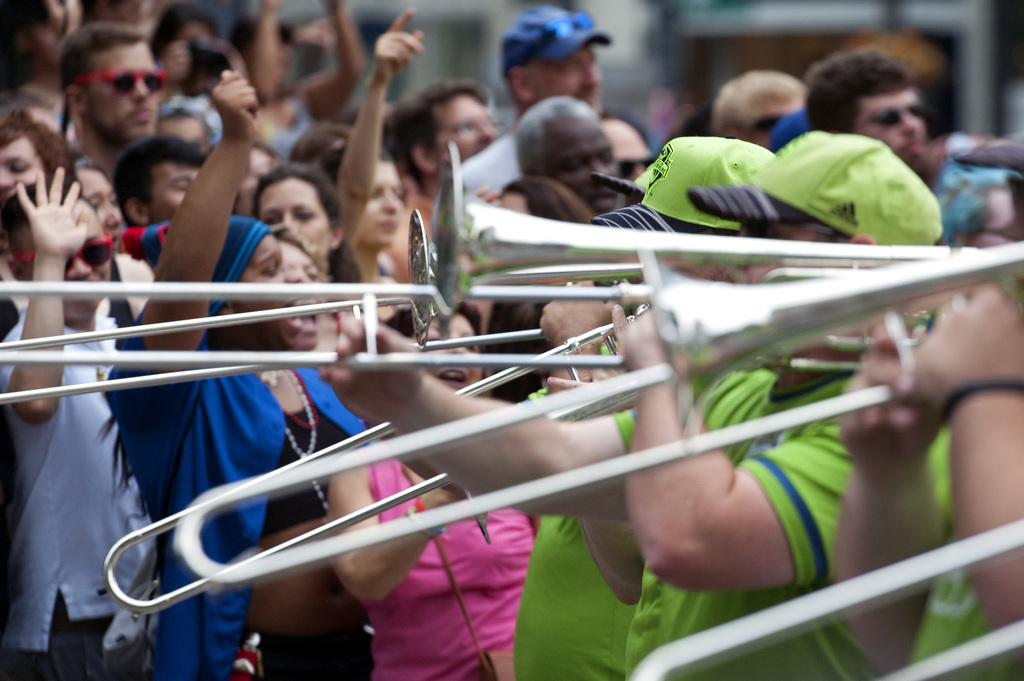How many men are present on the right side of the image? There are three men on the right side of the image. What are the men doing in the image? The men are standing and playing trumpets. Can you describe the background of the image? There is a crowd in the background of the image. What type of stocking is the grandfather wearing in the image? There is no grandfather or stocking present in the image. How many passengers are visible in the image? There is no reference to passengers in the image; it features three men playing trumpets. 